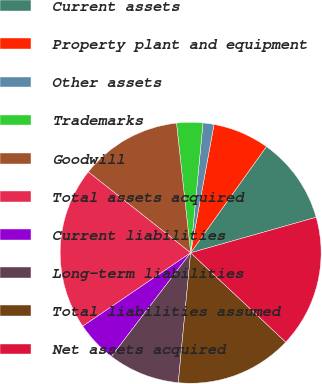Convert chart to OTSL. <chart><loc_0><loc_0><loc_500><loc_500><pie_chart><fcel>Current assets<fcel>Property plant and equipment<fcel>Other assets<fcel>Trademarks<fcel>Goodwill<fcel>Total assets acquired<fcel>Current liabilities<fcel>Long-term liabilities<fcel>Total liabilities assumed<fcel>Net assets acquired<nl><fcel>10.75%<fcel>6.99%<fcel>1.36%<fcel>3.24%<fcel>12.63%<fcel>20.15%<fcel>5.11%<fcel>8.87%<fcel>14.51%<fcel>16.39%<nl></chart> 